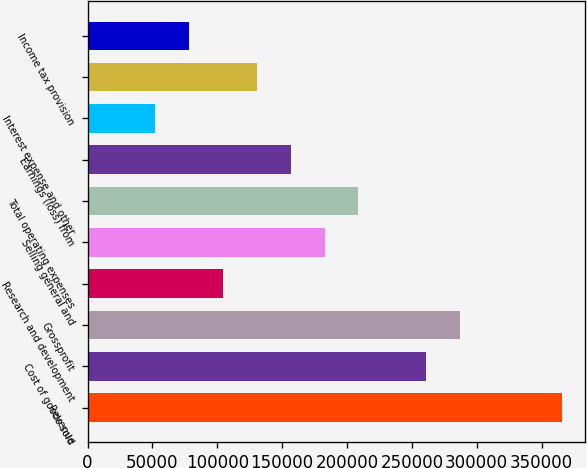Convert chart to OTSL. <chart><loc_0><loc_0><loc_500><loc_500><bar_chart><fcel>Revenue<fcel>Cost of goods sold<fcel>Grossprofit<fcel>Research and development<fcel>Selling general and<fcel>Total operating expenses<fcel>Earnings (loss) from<fcel>Interest expense and other<fcel>Unnamed: 8<fcel>Income tax provision<nl><fcel>365511<fcel>261080<fcel>287188<fcel>104433<fcel>182757<fcel>208864<fcel>156649<fcel>52217.9<fcel>130541<fcel>78325.6<nl></chart> 